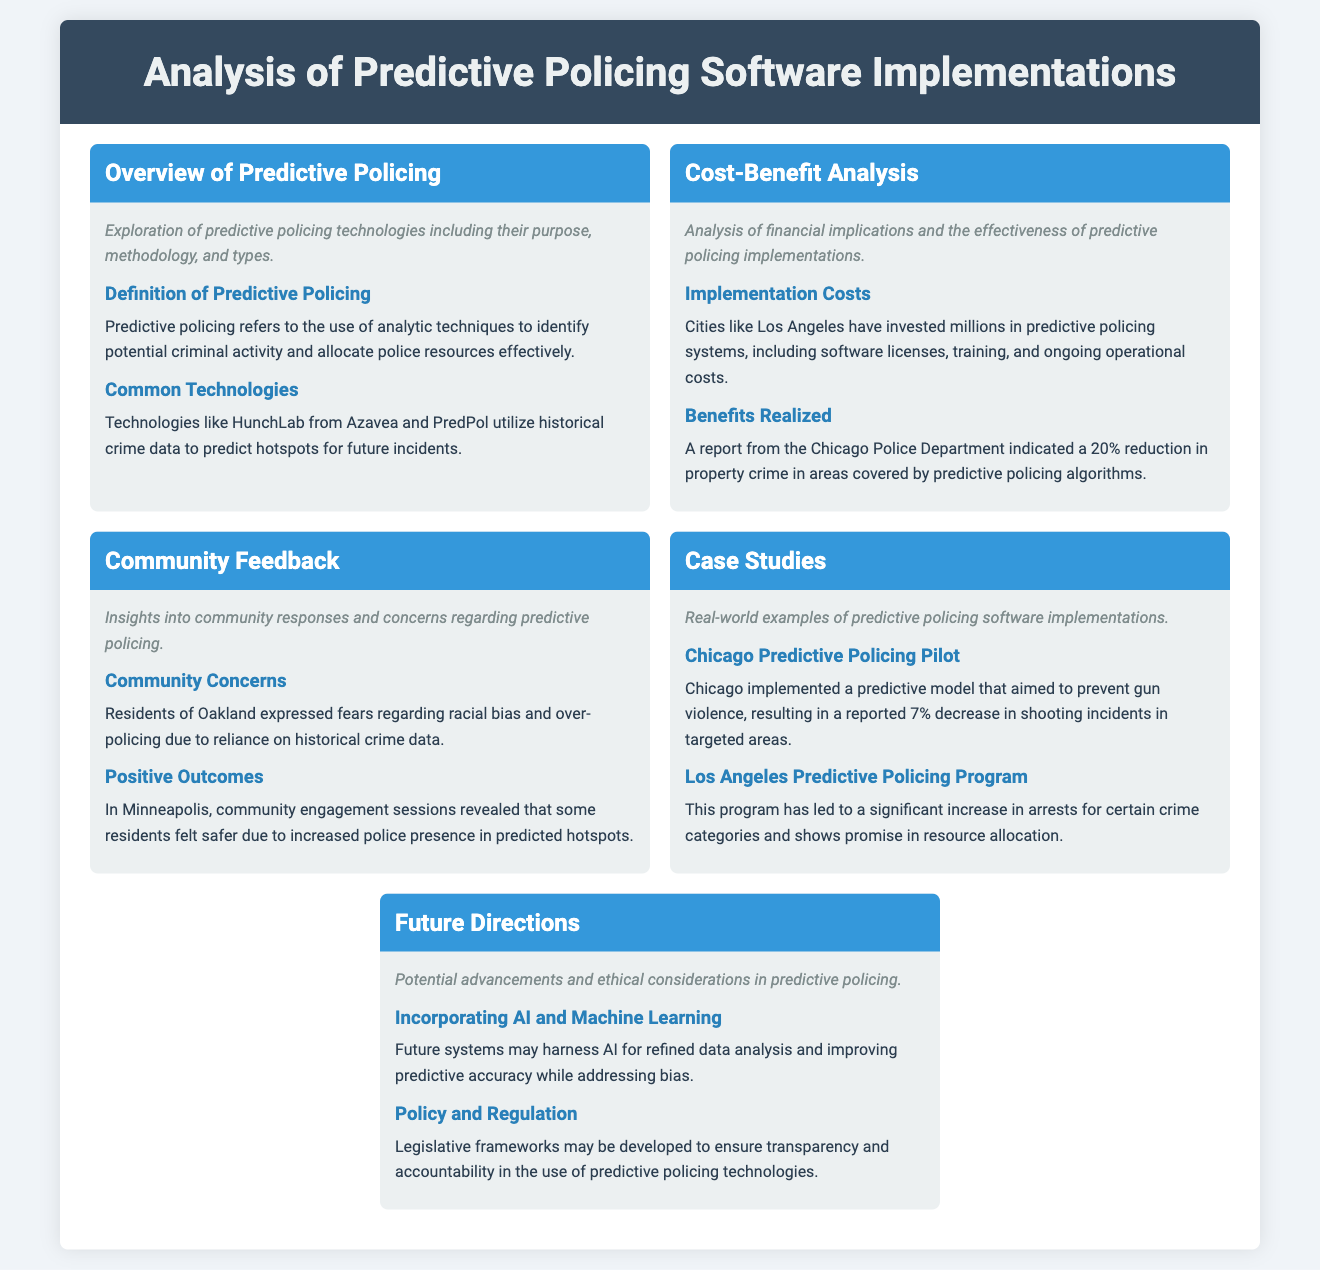What is predictive policing? Predictive policing is defined in the document as the use of analytic techniques to identify potential criminal activity and allocate police resources effectively.
Answer: Use of analytic techniques What city saw a 20% reduction in property crime? The document mentions a report from the Chicago Police Department highlighting the reduction in property crime in areas covered by predictive policing algorithms.
Answer: Chicago What are the common technologies used in predictive policing? The document identifies HunchLab from Azavea and PredPol as common technologies that utilize historical crime data.
Answer: HunchLab and PredPol What was the outcome of the Chicago Predictive Policing Pilot? The document states that Chicago implemented a predictive model aiming to prevent gun violence, resulting in a reported 7% decrease in shooting incidents in targeted areas.
Answer: 7% decrease What concern did residents of Oakland express? The document records that residents of Oakland expressed fears regarding racial bias and over-policing due to reliance on historical crime data.
Answer: Racial bias What is one potential direction for future predictive policing technologies mentioned in the document? The document indicates that future systems may harness AI for refined data analysis and improving predictive accuracy while addressing bias.
Answer: Incorporating AI How much have cities like Los Angeles invested in predictive policing systems? The document mentions that cities like Los Angeles have invested millions in predictive policing systems, including software licenses, training, and operational costs.
Answer: Millions What is the focus of community engagement sessions in Minneapolis? The document indicates that community engagement sessions in Minneapolis revealed that some residents felt safer due to increased police presence in predicted hotspots.
Answer: Increased police presence 